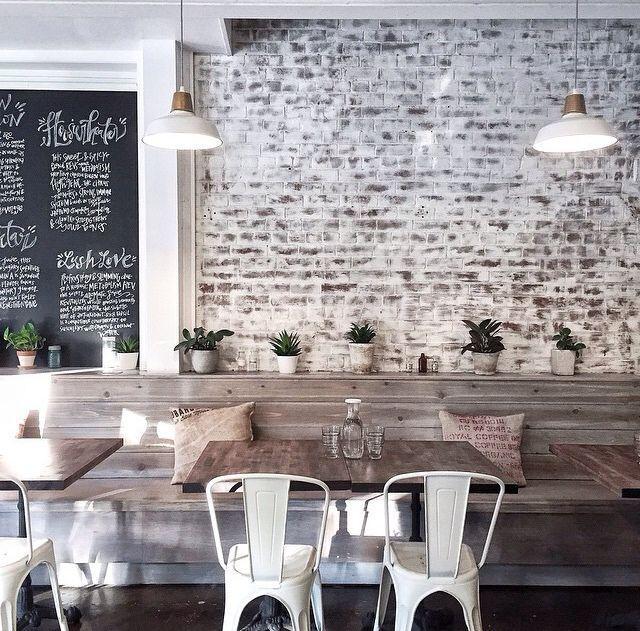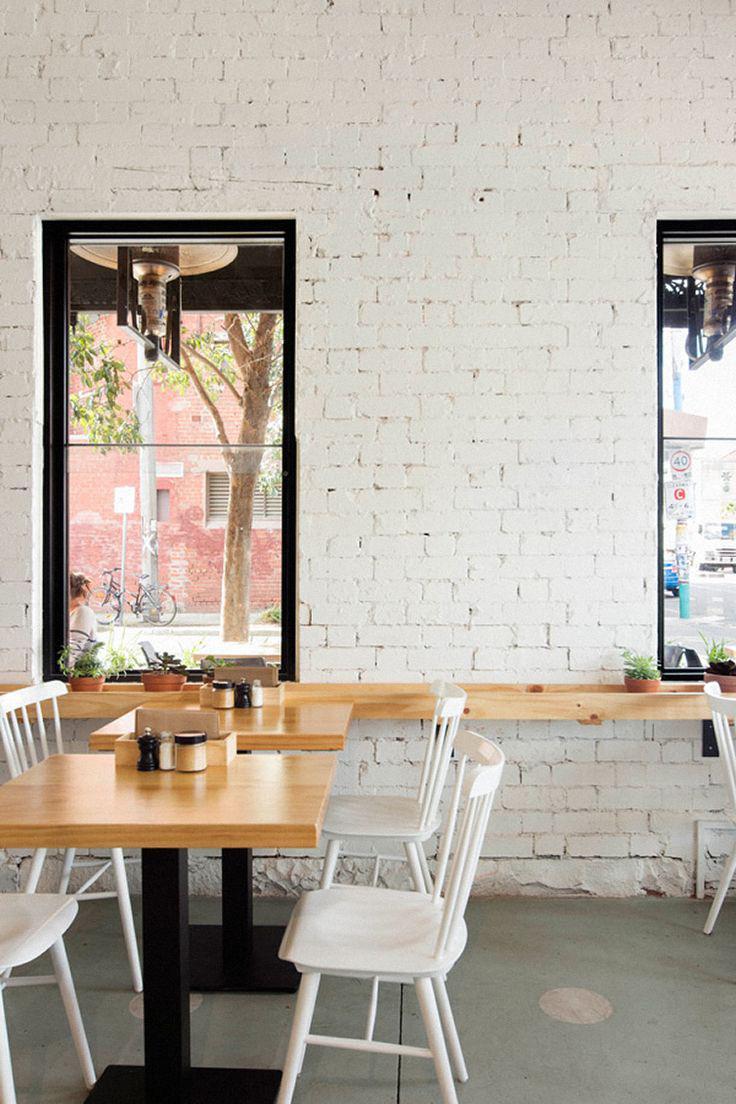The first image is the image on the left, the second image is the image on the right. Considering the images on both sides, is "Each image shows a cafe with seating on white chairs near an interior brick wall, but potted plants are in only one image." valid? Answer yes or no. Yes. The first image is the image on the left, the second image is the image on the right. For the images displayed, is the sentence "Some of the white chairs are made of metal." factually correct? Answer yes or no. Yes. 